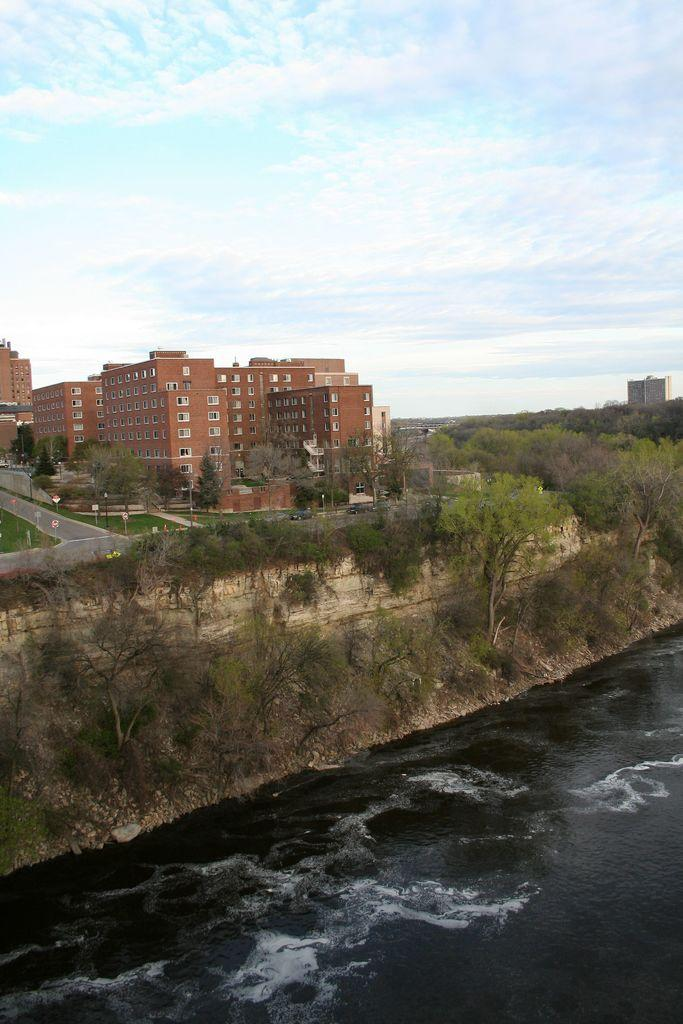What type of structures can be seen in the image? There are buildings in the image. What other natural elements are present in the image? There are trees in the image. What man-made objects can be seen in the image? There are poles and boards visible in the image. What is happening on the road in the image? There are vehicles on the road in the image. What can be seen in the sky at the top of the image? There are clouds in the sky at the top of the image. What is visible at the bottom of the image? There is water visible at the bottom of the image. Can you tell me how many times the organization is mentioned in the image? There is no mention of an organization in the image. What type of bun is being used to hold the hair of the person in the image? There is no person or hair visible in the image. 